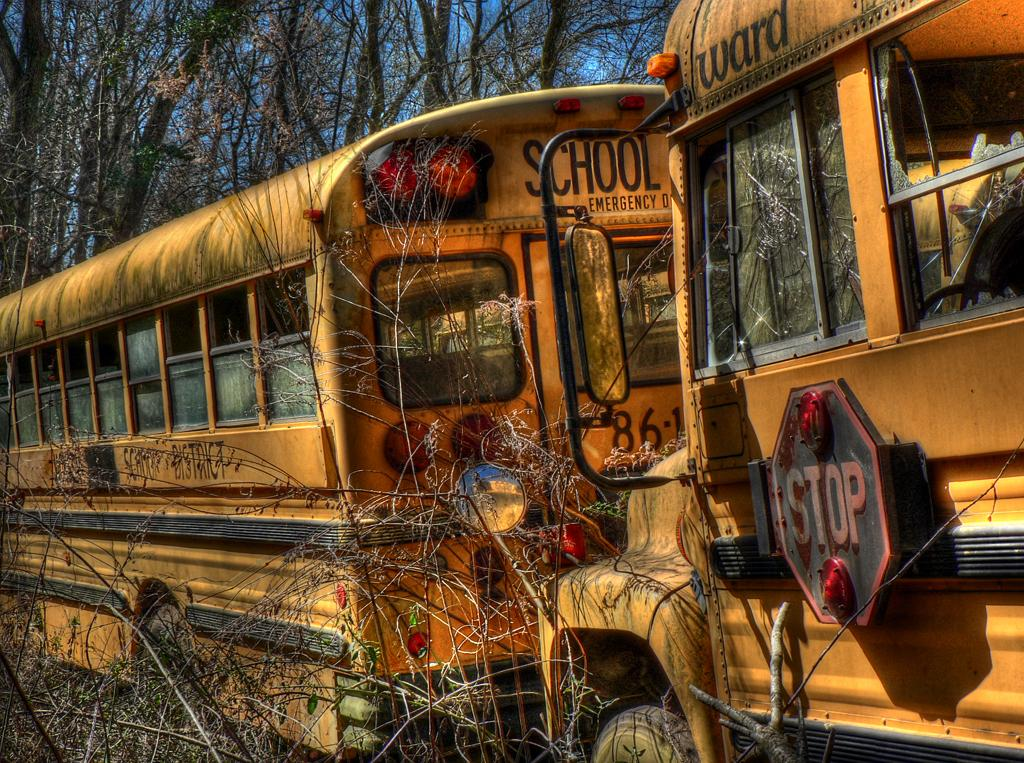What type of vehicles are present in the image? There are buses in the image. What is the surrounding environment of the buses? The buses are surrounded by trees. What can be seen in the background of the image? There is a sky visible in the background of the image. How many rings are visible on the wrist of the bus driver in the image? There is no bus driver present in the image, and therefore no wrist or rings can be observed. 